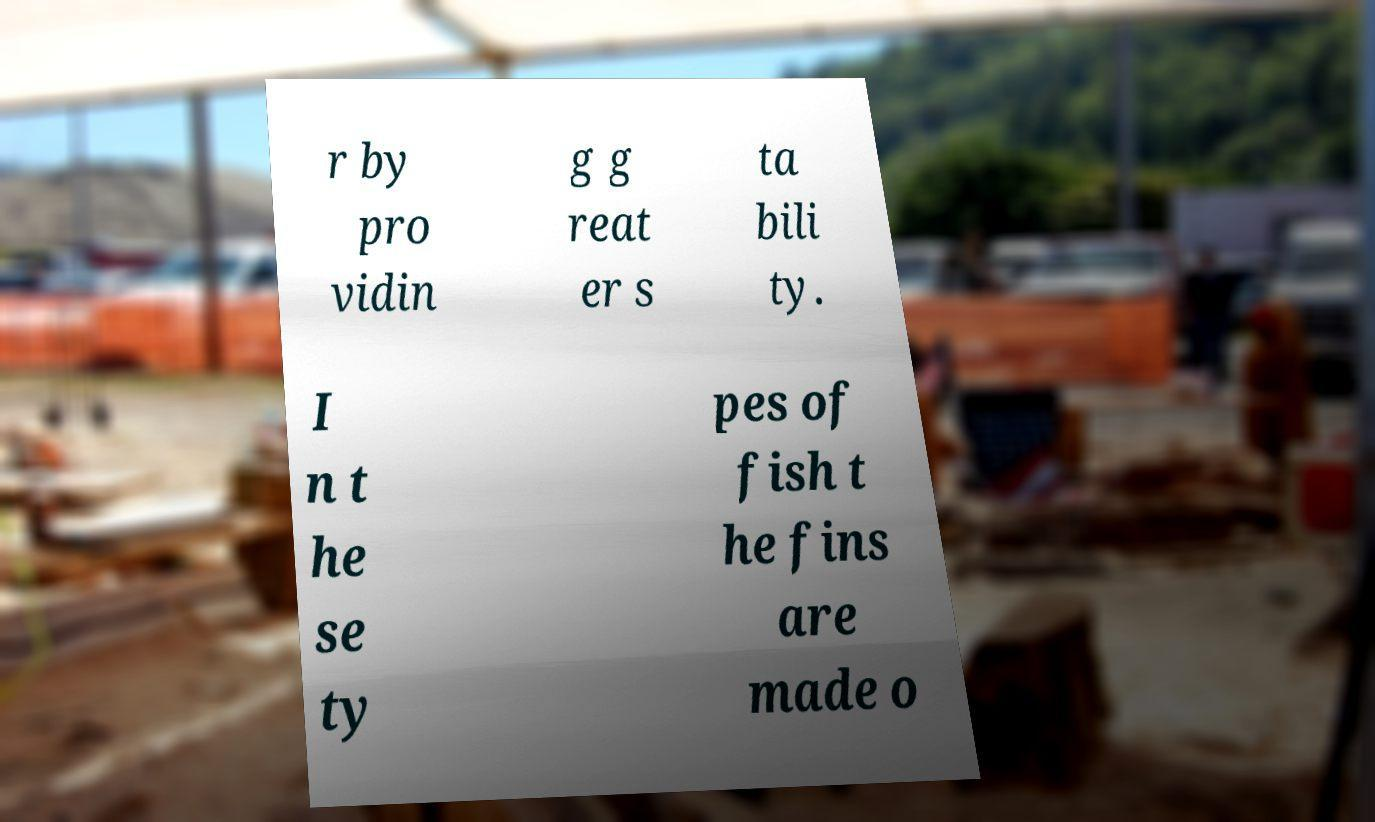I need the written content from this picture converted into text. Can you do that? r by pro vidin g g reat er s ta bili ty. I n t he se ty pes of fish t he fins are made o 